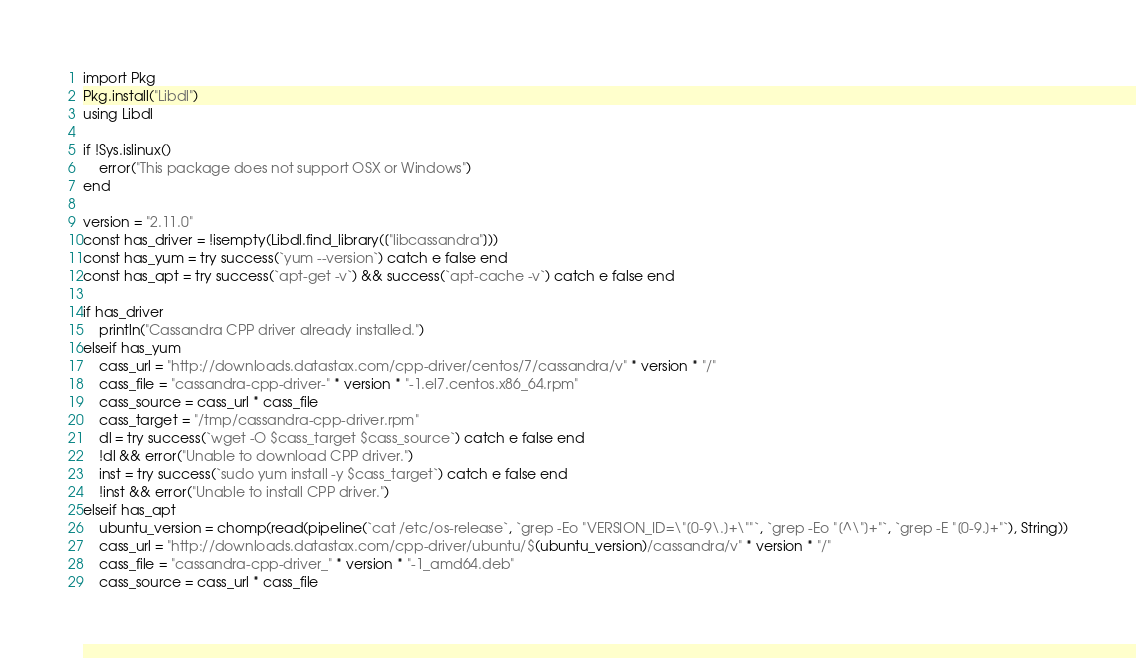<code> <loc_0><loc_0><loc_500><loc_500><_Julia_>import Pkg
Pkg.install("Libdl")
using Libdl

if !Sys.islinux()
    error("This package does not support OSX or Windows")
end

version = "2.11.0"
const has_driver = !isempty(Libdl.find_library(["libcassandra"]))
const has_yum = try success(`yum --version`) catch e false end
const has_apt = try success(`apt-get -v`) && success(`apt-cache -v`) catch e false end

if has_driver
    println("Cassandra CPP driver already installed.")
elseif has_yum
    cass_url = "http://downloads.datastax.com/cpp-driver/centos/7/cassandra/v" * version * "/"
    cass_file = "cassandra-cpp-driver-" * version * "-1.el7.centos.x86_64.rpm"
    cass_source = cass_url * cass_file
    cass_target = "/tmp/cassandra-cpp-driver.rpm"
    dl = try success(`wget -O $cass_target $cass_source`) catch e false end
    !dl && error("Unable to download CPP driver.")
    inst = try success(`sudo yum install -y $cass_target`) catch e false end
    !inst && error("Unable to install CPP driver.")
elseif has_apt
    ubuntu_version = chomp(read(pipeline(`cat /etc/os-release`, `grep -Eo "VERSION_ID=\"[0-9\.]+\""`, `grep -Eo "[^\"]+"`, `grep -E "[0-9.]+"`), String))
    cass_url = "http://downloads.datastax.com/cpp-driver/ubuntu/$(ubuntu_version)/cassandra/v" * version * "/"
    cass_file = "cassandra-cpp-driver_" * version * "-1_amd64.deb"
    cass_source = cass_url * cass_file</code> 